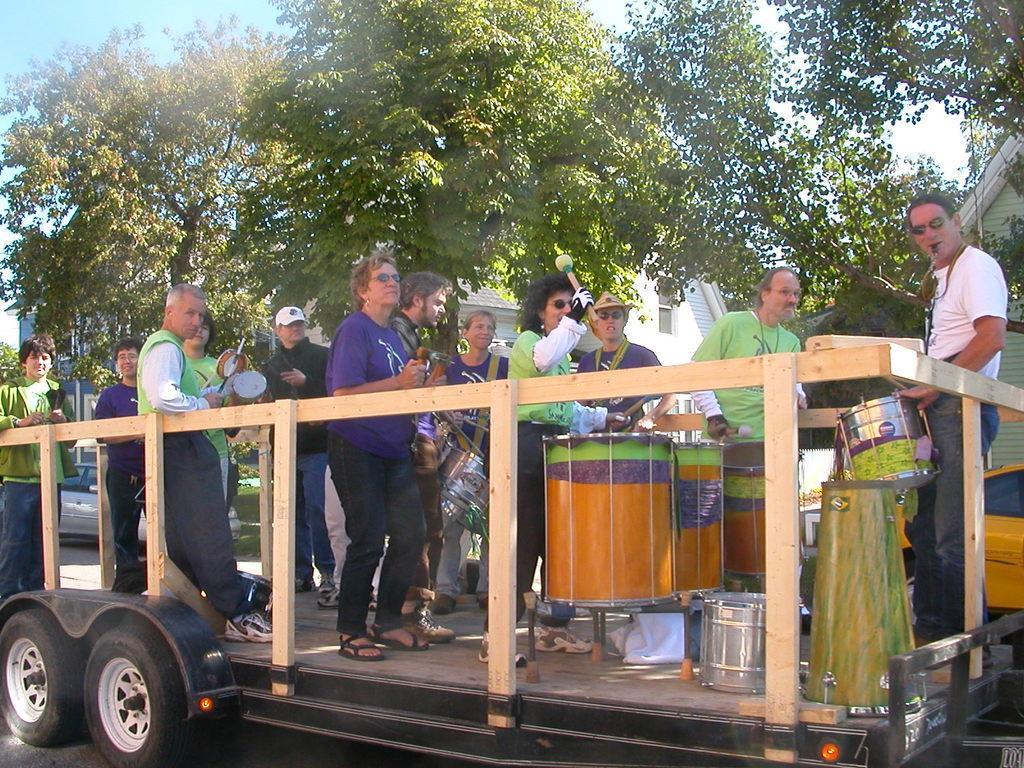Could you give a brief overview of what you see in this image? In this image In the middle there is a vehicle on that there are many people ,drumsticks and some musical instruments. In the background there are houses, trees and sky. 